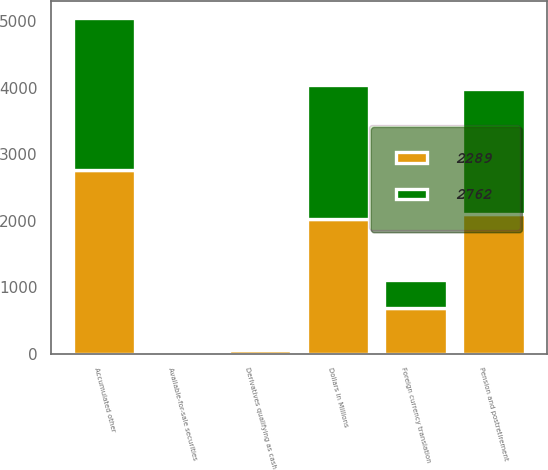Convert chart to OTSL. <chart><loc_0><loc_0><loc_500><loc_500><stacked_bar_chart><ecel><fcel>Dollars in Millions<fcel>Derivatives qualifying as cash<fcel>Pension and postretirement<fcel>Available-for-sale securities<fcel>Foreign currency translation<fcel>Accumulated other<nl><fcel>2289<fcel>2018<fcel>51<fcel>2102<fcel>30<fcel>681<fcel>2762<nl><fcel>2762<fcel>2017<fcel>19<fcel>1883<fcel>32<fcel>419<fcel>2289<nl></chart> 